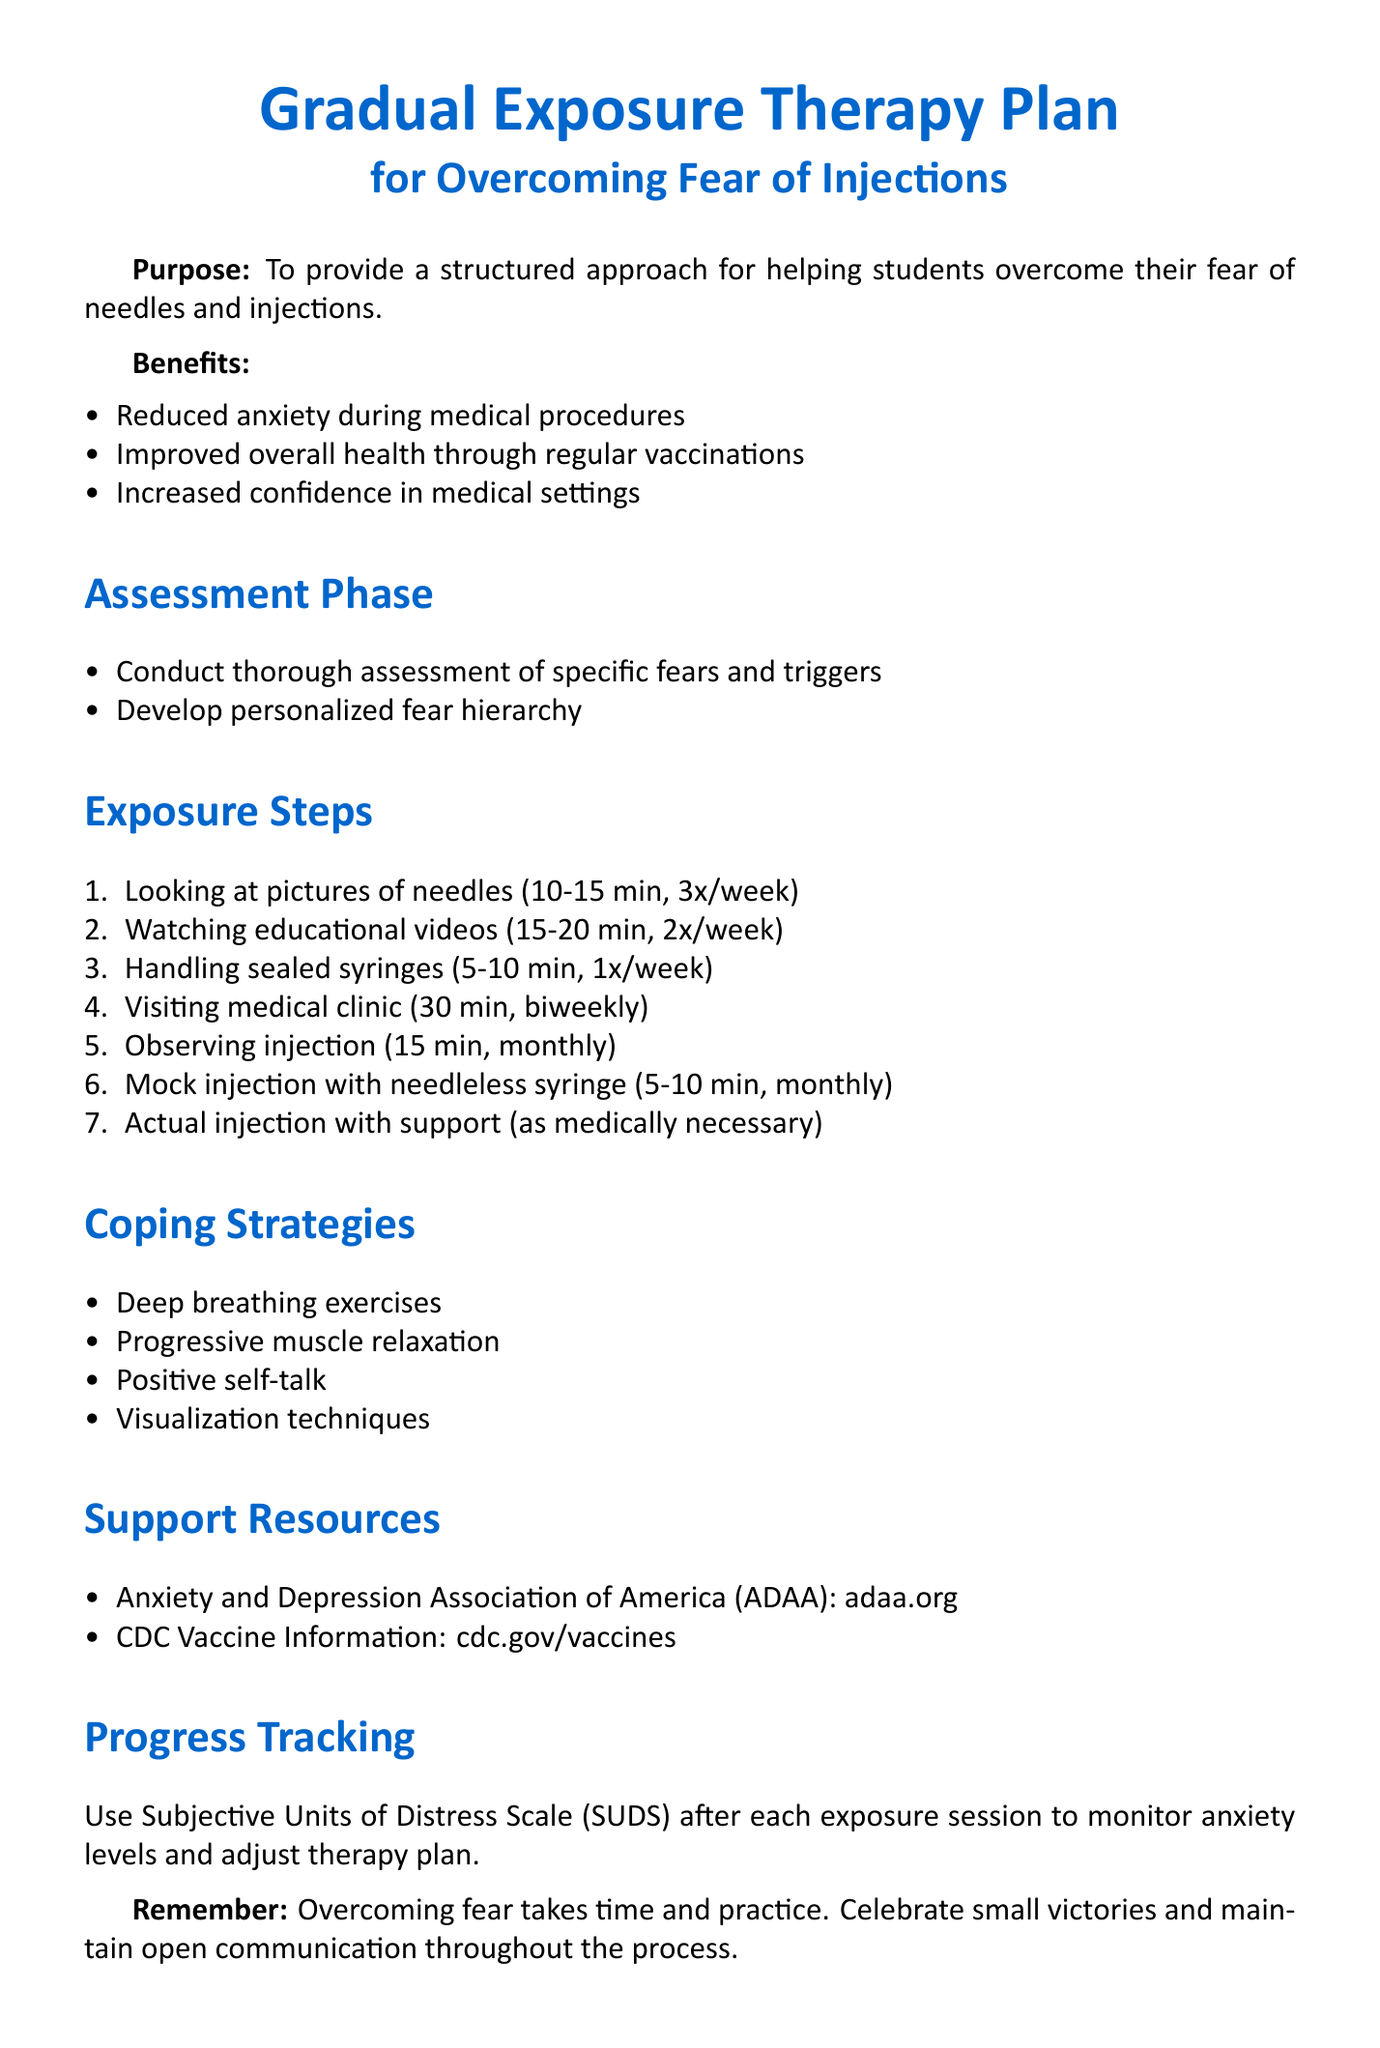What is the title of the memo? The title is stated at the beginning of the document, indicating its purpose clearly.
Answer: Gradual Exposure Therapy Plan for Overcoming Fear of Injections What is one benefit of overcoming fear mentioned in the memo? The benefits are listed under a specific section that highlights the advantages of overcoming fear.
Answer: Reduced anxiety during medical procedures What is the duration of the first exposure step? The duration for viewing pictures of needles is specified in the exposure steps section.
Answer: 10-15 minutes per session How often should the second exposure step be done? The frequency of watching educational videos is detailed in the exposure steps section.
Answer: 2 times per week What coping strategy involves breathing techniques? The coping strategies section lists various methods, including deep breathing exercises.
Answer: Deep breathing exercises What is the method used for progress tracking? The method is mentioned in the progress tracking section to monitor anxiety levels.
Answer: Subjective Units of Distress Scale (SUDS) How many steps are there in the exposure plan? The total number of exposure steps can be calculated by counting each listed step in the exposure steps section.
Answer: 7 What does the conclusion emphasize about the process? The memo includes key takeaways in the conclusion, emphasizing the nature of overcoming fear.
Answer: Patience What organization provides additional resources for anxiety disorders? The support resources section names an organization with relevant information on anxiety.
Answer: Anxiety and Depression Association of America (ADAA) 